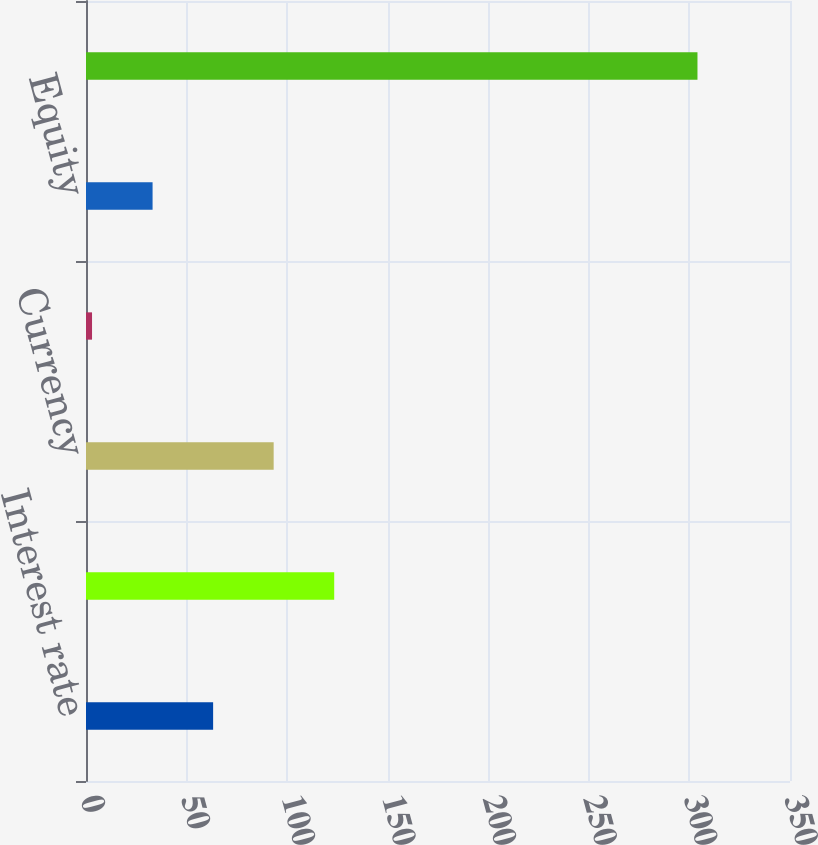Convert chart. <chart><loc_0><loc_0><loc_500><loc_500><bar_chart><fcel>Interest rate<fcel>Currency(1)<fcel>Currency<fcel>Credit<fcel>Equity<fcel>Total Derivative Impact<nl><fcel>63.2<fcel>123.4<fcel>93.3<fcel>3<fcel>33.1<fcel>304<nl></chart> 